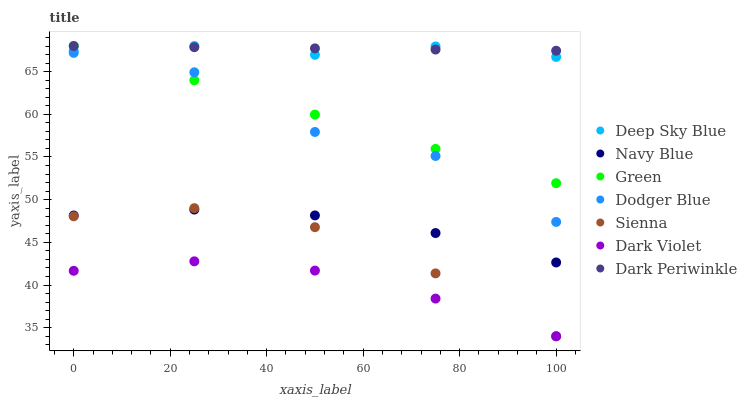Does Dark Violet have the minimum area under the curve?
Answer yes or no. Yes. Does Dark Periwinkle have the maximum area under the curve?
Answer yes or no. Yes. Does Sienna have the minimum area under the curve?
Answer yes or no. No. Does Sienna have the maximum area under the curve?
Answer yes or no. No. Is Green the smoothest?
Answer yes or no. Yes. Is Dodger Blue the roughest?
Answer yes or no. Yes. Is Dark Violet the smoothest?
Answer yes or no. No. Is Dark Violet the roughest?
Answer yes or no. No. Does Dark Violet have the lowest value?
Answer yes or no. Yes. Does Green have the lowest value?
Answer yes or no. No. Does Dark Periwinkle have the highest value?
Answer yes or no. Yes. Does Sienna have the highest value?
Answer yes or no. No. Is Dark Violet less than Navy Blue?
Answer yes or no. Yes. Is Dodger Blue greater than Navy Blue?
Answer yes or no. Yes. Does Navy Blue intersect Sienna?
Answer yes or no. Yes. Is Navy Blue less than Sienna?
Answer yes or no. No. Is Navy Blue greater than Sienna?
Answer yes or no. No. Does Dark Violet intersect Navy Blue?
Answer yes or no. No. 